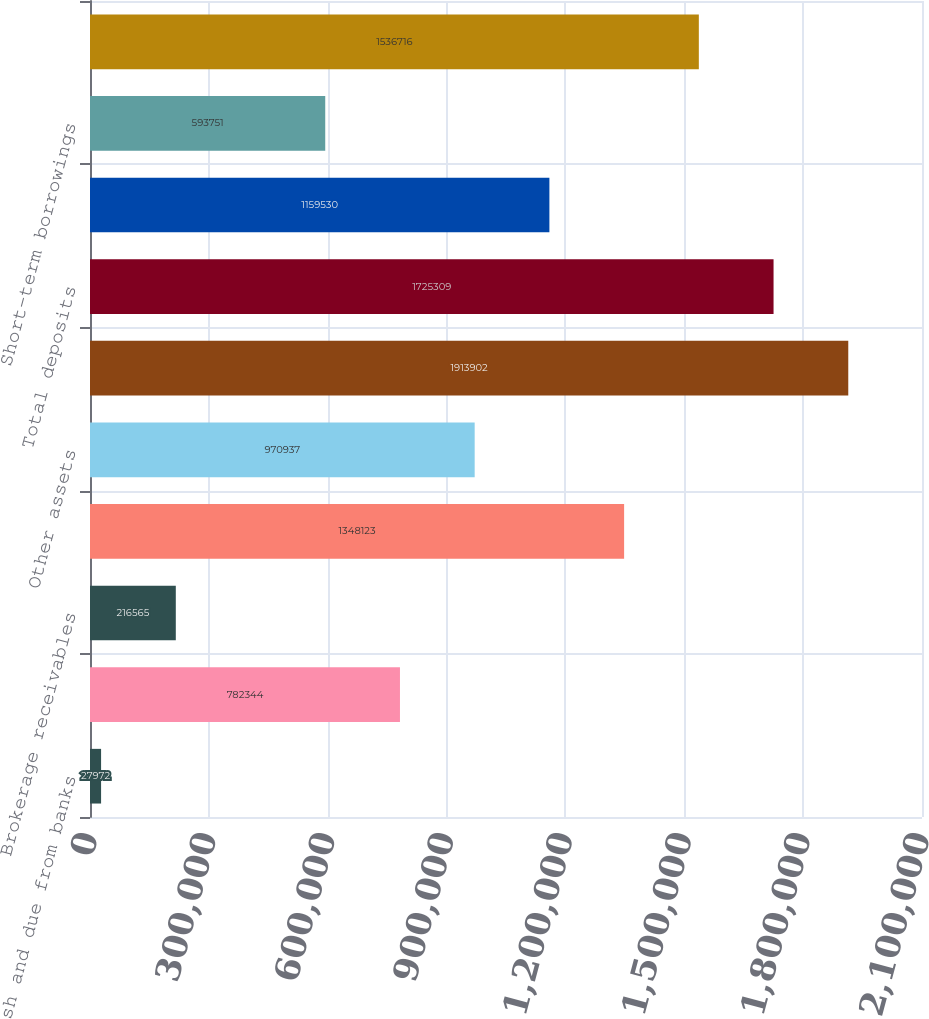<chart> <loc_0><loc_0><loc_500><loc_500><bar_chart><fcel>Cash and due from banks<fcel>Deposits with banks<fcel>Brokerage receivables<fcel>Investments<fcel>Other assets<fcel>Total assets<fcel>Total deposits<fcel>agreements to repurchase<fcel>Short-term borrowings<fcel>Long-term debt<nl><fcel>27972<fcel>782344<fcel>216565<fcel>1.34812e+06<fcel>970937<fcel>1.9139e+06<fcel>1.72531e+06<fcel>1.15953e+06<fcel>593751<fcel>1.53672e+06<nl></chart> 